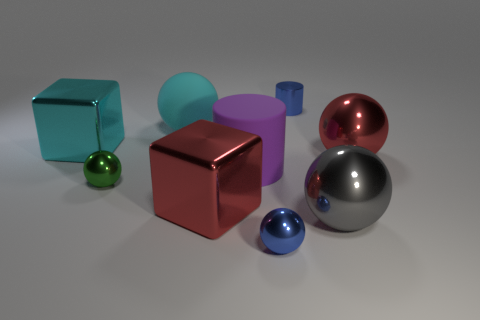Subtract all cyan matte balls. How many balls are left? 4 Subtract all cyan spheres. How many spheres are left? 4 Subtract 2 balls. How many balls are left? 3 Add 1 green metallic spheres. How many objects exist? 10 Subtract all spheres. How many objects are left? 4 Subtract all cyan balls. Subtract all green cubes. How many balls are left? 4 Add 1 red things. How many red things are left? 3 Add 1 tiny cylinders. How many tiny cylinders exist? 2 Subtract 1 blue cylinders. How many objects are left? 8 Subtract all large purple rubber things. Subtract all small blue metal balls. How many objects are left? 7 